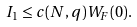<formula> <loc_0><loc_0><loc_500><loc_500>I _ { 1 } \leq c ( N , q ) W _ { F } ( 0 ) .</formula> 